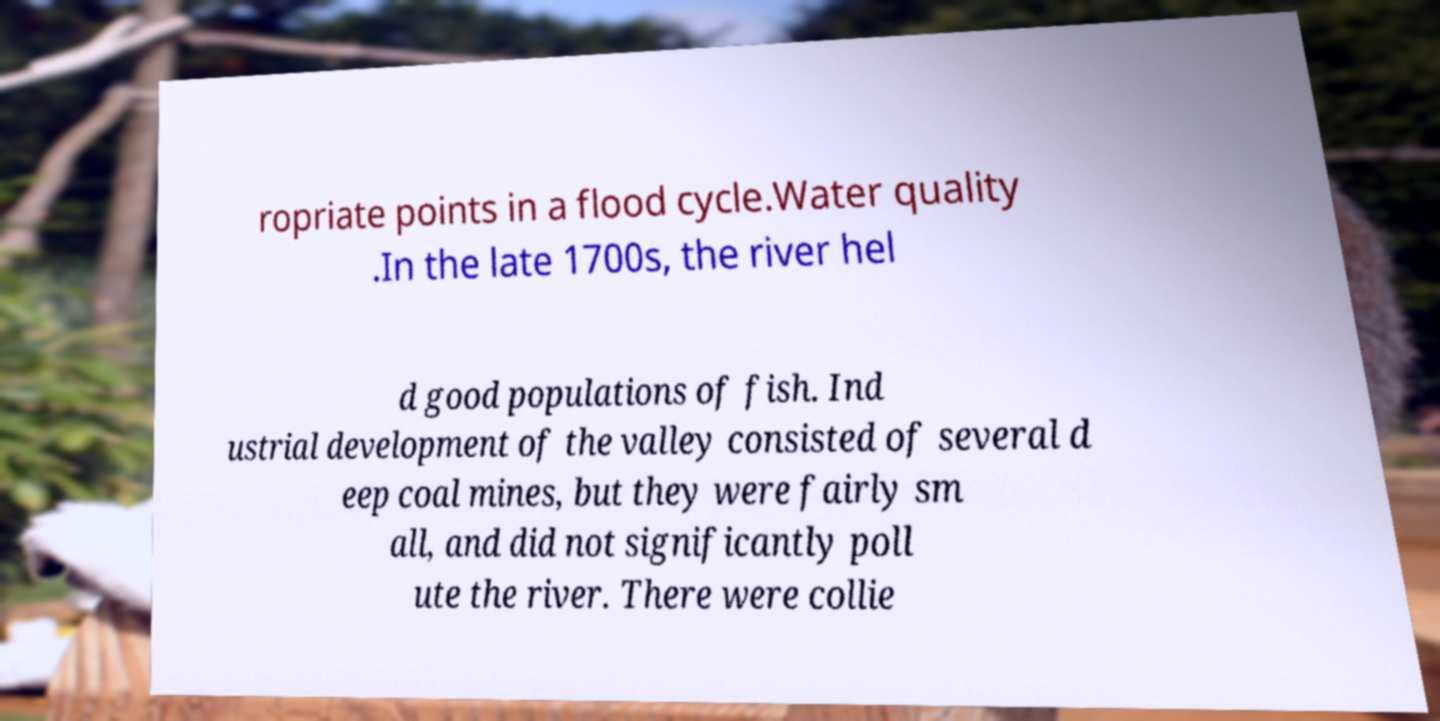There's text embedded in this image that I need extracted. Can you transcribe it verbatim? ropriate points in a flood cycle.Water quality .In the late 1700s, the river hel d good populations of fish. Ind ustrial development of the valley consisted of several d eep coal mines, but they were fairly sm all, and did not significantly poll ute the river. There were collie 